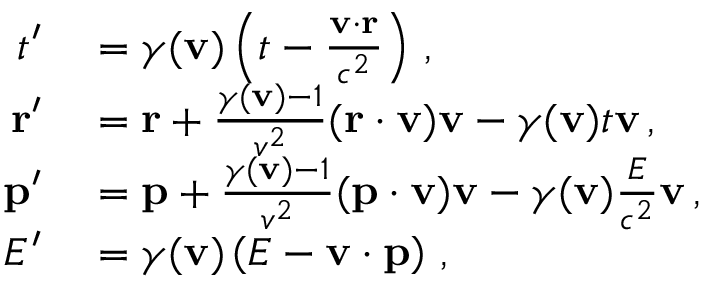<formula> <loc_0><loc_0><loc_500><loc_500>\begin{array} { r l } { t ^ { \prime } } & = \gamma ( v ) \left ( t - { \frac { v \cdot r } { c ^ { 2 } } } \right ) \, , } \\ { r ^ { \prime } } & = r + { \frac { \gamma ( v ) - 1 } { v ^ { 2 } } } ( r \cdot v ) v - \gamma ( v ) t v \, , } \\ { p ^ { \prime } } & = p + { \frac { \gamma ( v ) - 1 } { v ^ { 2 } } } ( p \cdot v ) v - \gamma ( v ) { \frac { E } { c ^ { 2 } } } v \, , } \\ { E ^ { \prime } } & = \gamma ( v ) \left ( E - v \cdot p \right ) \, , } \end{array}</formula> 